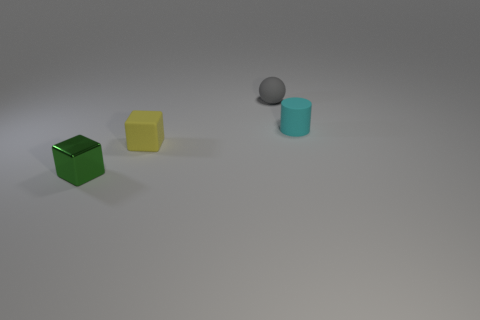Add 1 tiny balls. How many objects exist? 5 Subtract all balls. How many objects are left? 3 Subtract all cylinders. Subtract all small green cubes. How many objects are left? 2 Add 2 tiny matte objects. How many tiny matte objects are left? 5 Add 2 green metal objects. How many green metal objects exist? 3 Subtract 0 blue spheres. How many objects are left? 4 